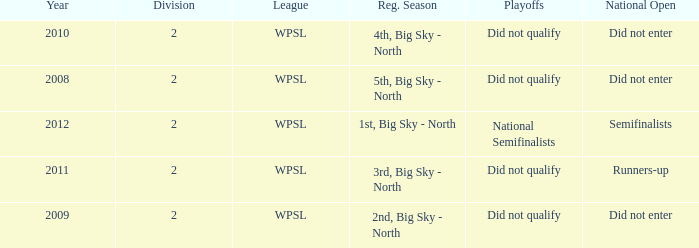What league was involved in 2008? WPSL. 